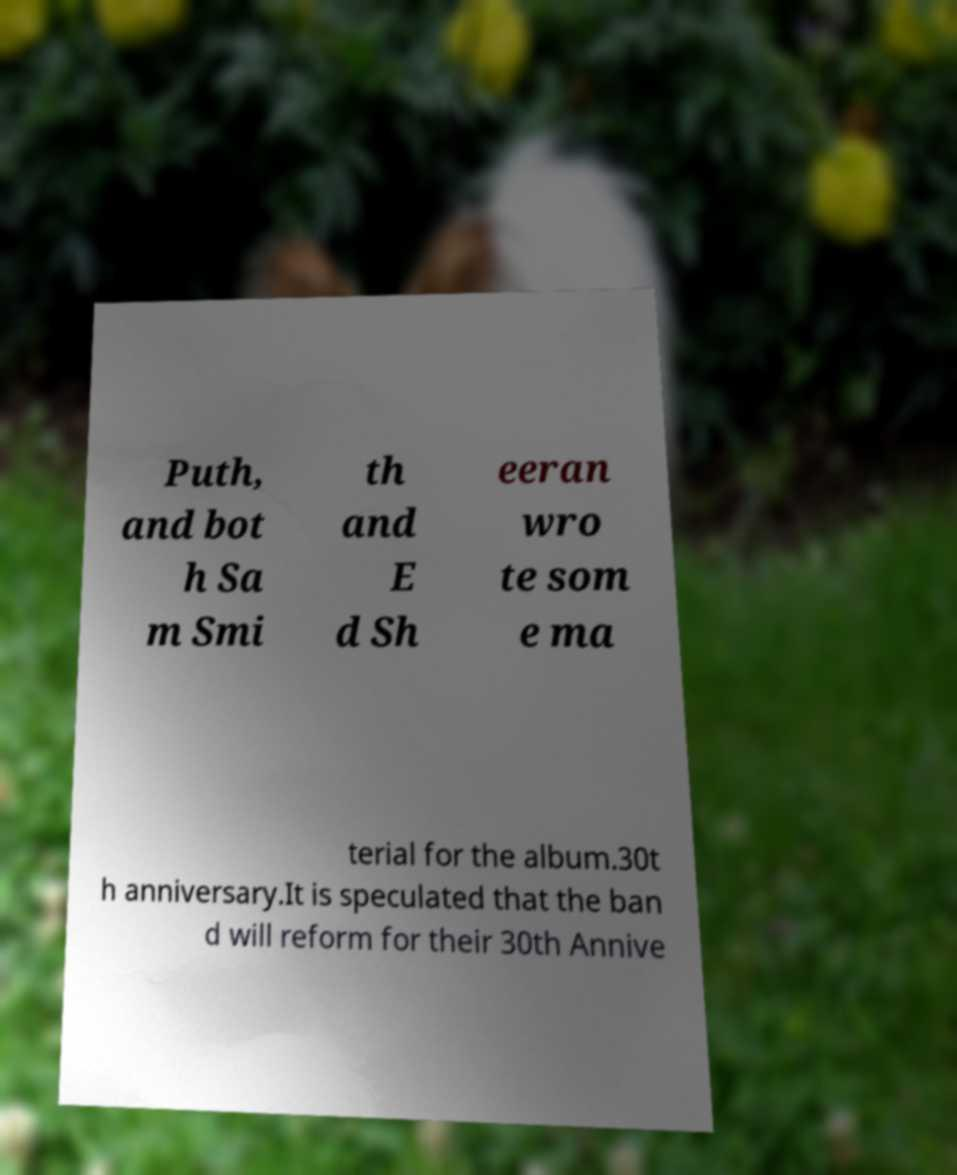Could you assist in decoding the text presented in this image and type it out clearly? Puth, and bot h Sa m Smi th and E d Sh eeran wro te som e ma terial for the album.30t h anniversary.It is speculated that the ban d will reform for their 30th Annive 